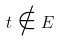<formula> <loc_0><loc_0><loc_500><loc_500>t \notin E</formula> 